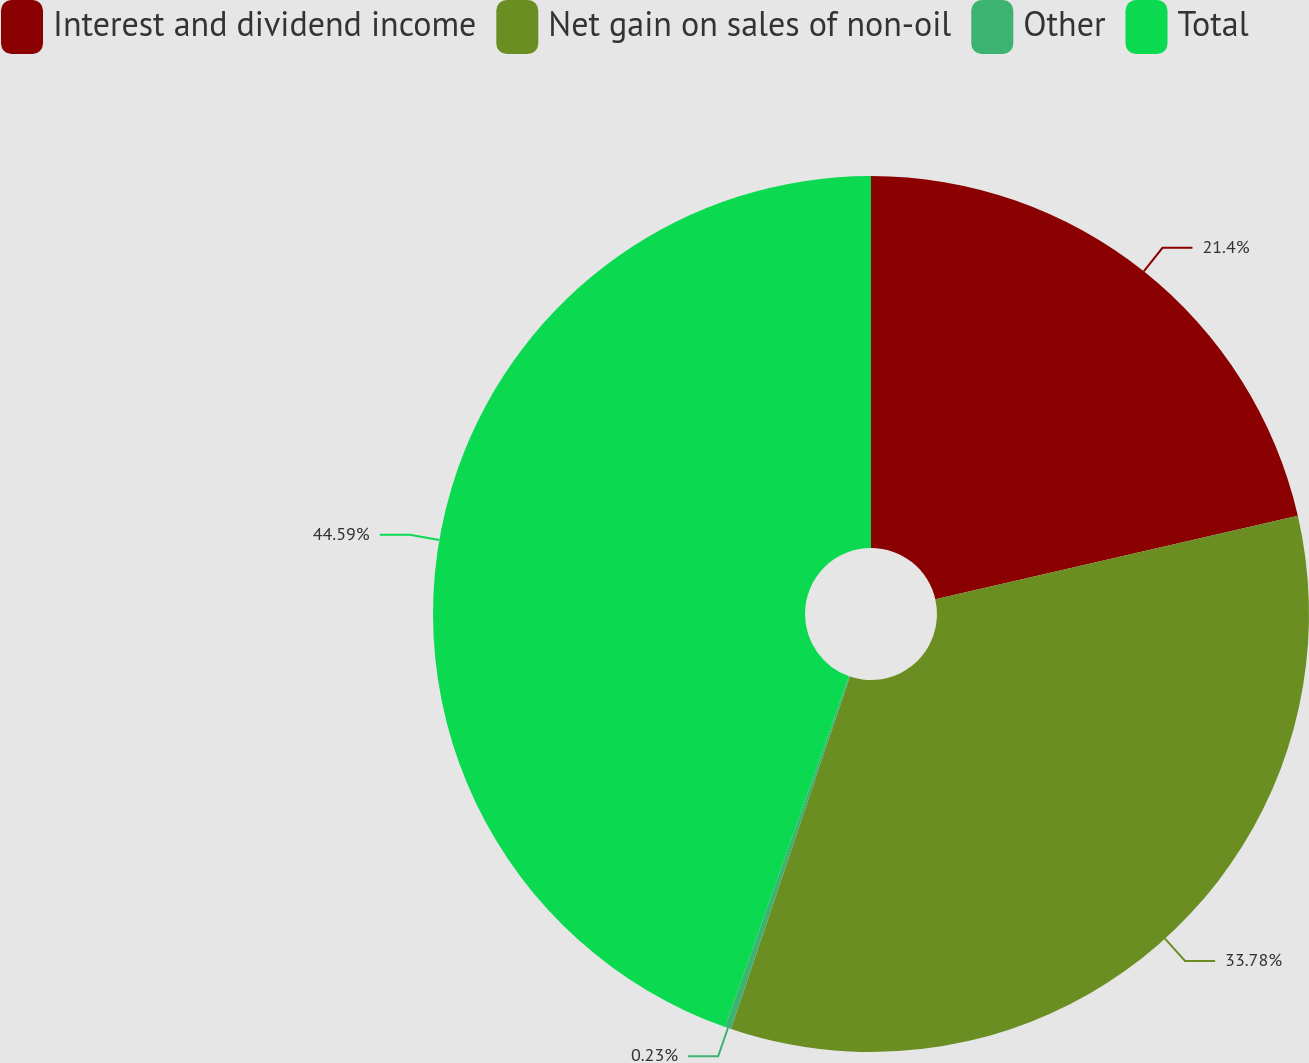Convert chart to OTSL. <chart><loc_0><loc_0><loc_500><loc_500><pie_chart><fcel>Interest and dividend income<fcel>Net gain on sales of non-oil<fcel>Other<fcel>Total<nl><fcel>21.4%<fcel>33.78%<fcel>0.23%<fcel>44.59%<nl></chart> 